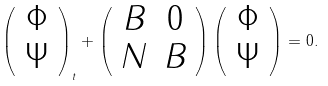Convert formula to latex. <formula><loc_0><loc_0><loc_500><loc_500>\left ( \begin{array} { c } \Phi \\ \Psi \end{array} \right ) _ { t } + \left ( \begin{array} { c c } B & 0 \\ N & B \end{array} \right ) \left ( \begin{array} { c } \Phi \\ \Psi \end{array} \right ) = 0 .</formula> 